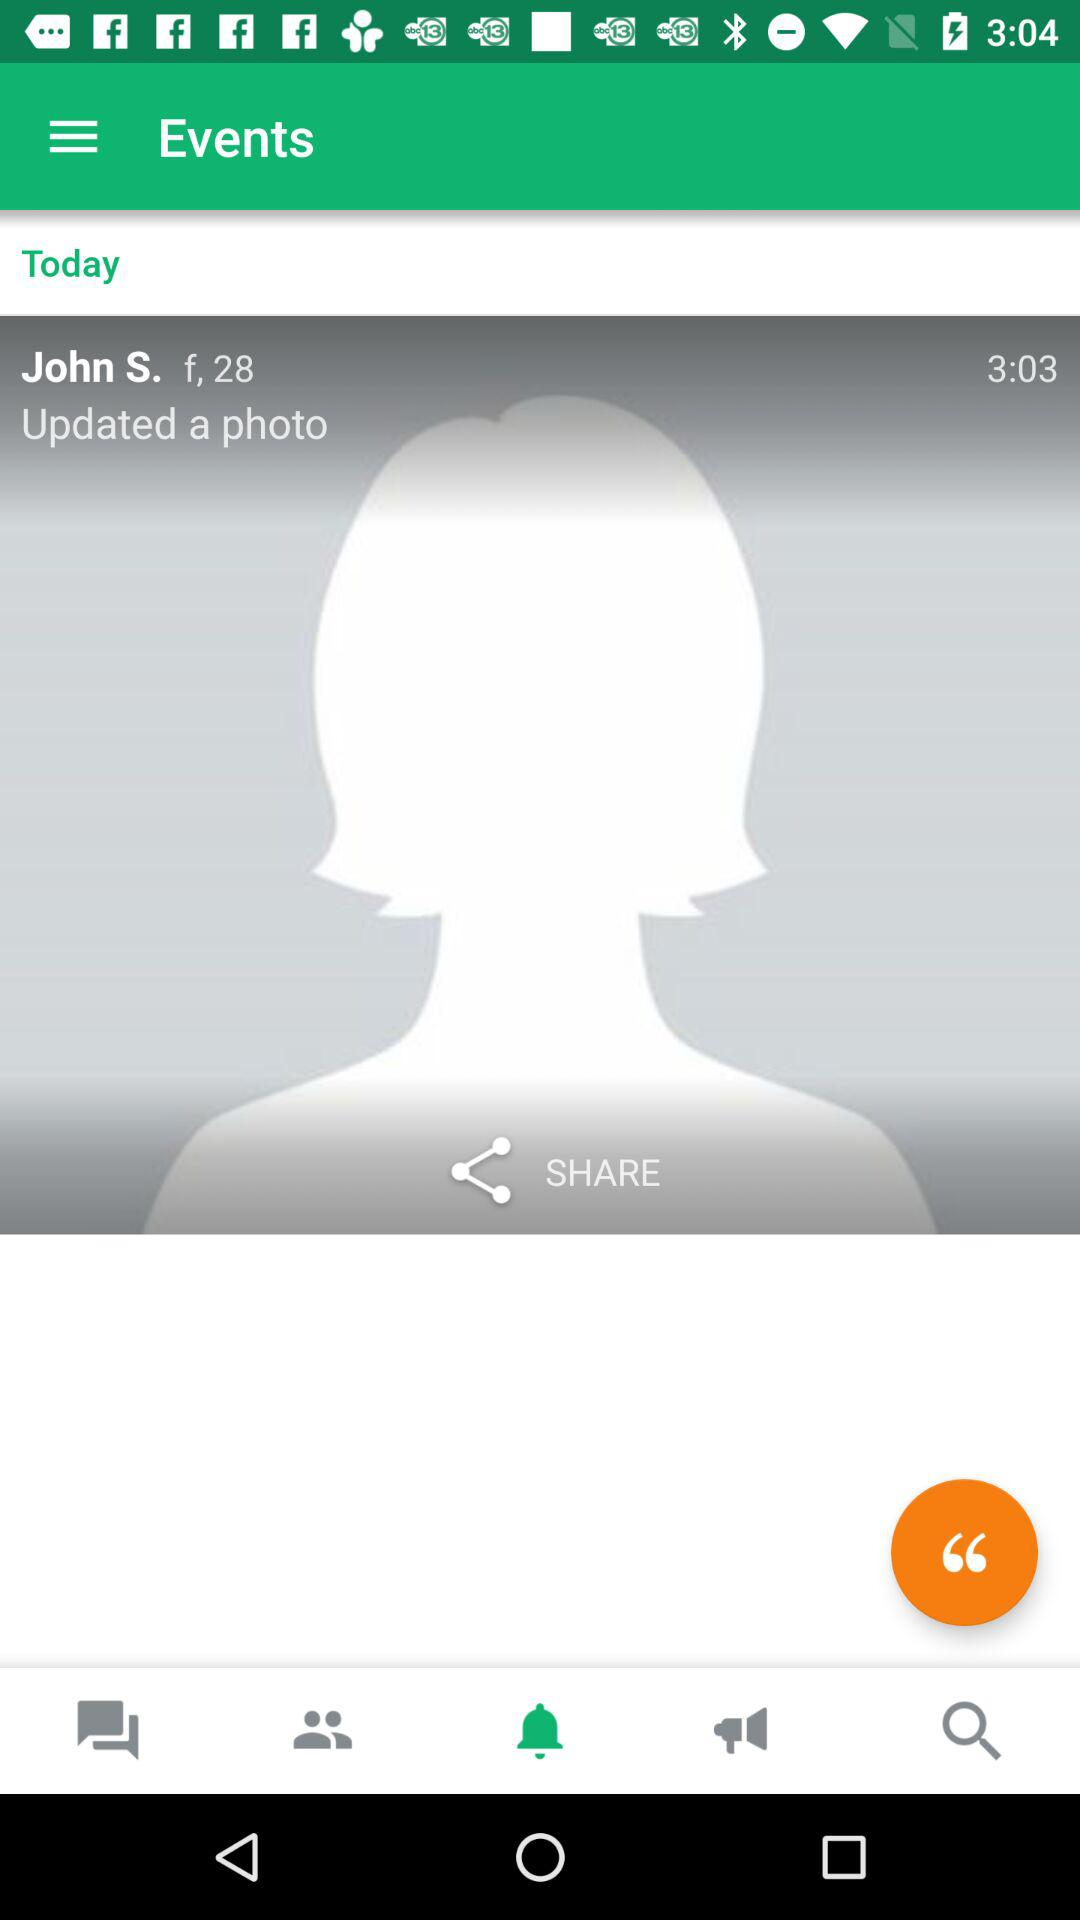What is the gender of the user? The gender is female. 